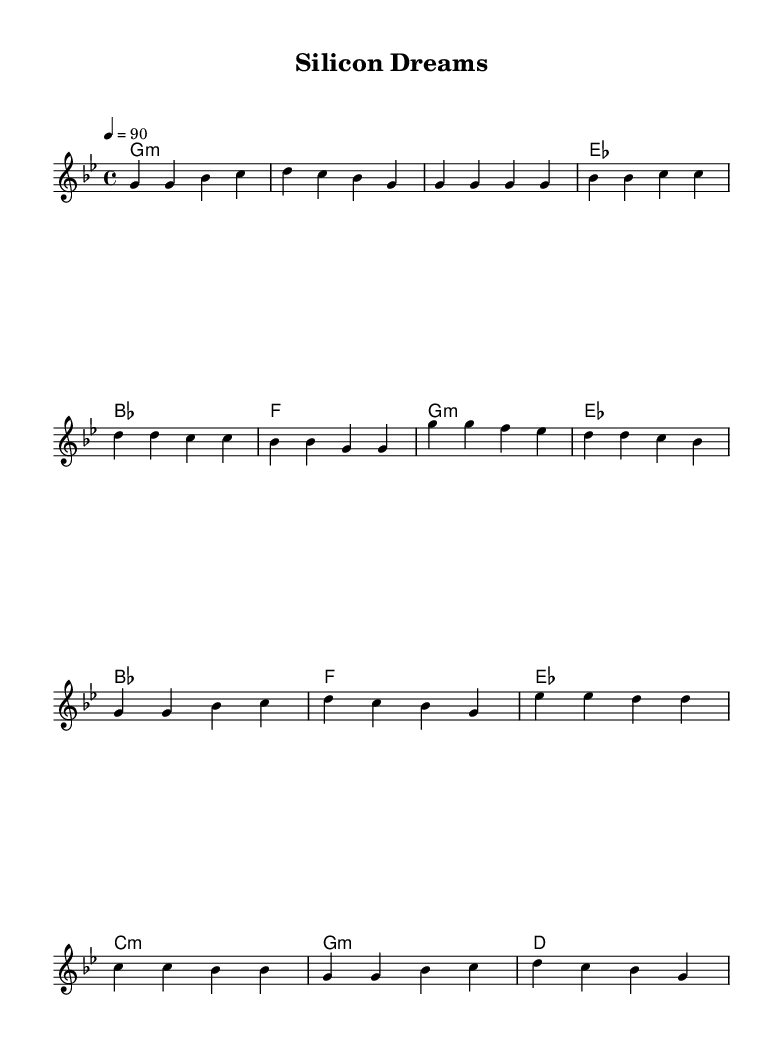What is the key signature of this music? The key signature is G minor, which includes B flat and E flat.
Answer: G minor What is the time signature of this music? The time signature is 4/4, indicating that there are four beats per measure.
Answer: 4/4 What is the tempo marking for this piece? The tempo marking indicates that the music should be played at a speed of 90 beats per minute.
Answer: 90 How many measures are in the verse section? The verse section consists of 4 measures, which can be counted directly from the melody section in the score.
Answer: 4 What is the first chord in the chorus? The first chord in the chorus is G minor, as indicated by the chord notation in the harmony section.
Answer: G minor What is the relationship between the chord progressions in the verse and the chorus? The chord progressions in both sections share the same chords, beginning with G minor, creating a coherent structure throughout the piece.
Answer: They are the same What rap theme is emphasized in the lyrics of this piece? The rap theme emphasizes tech entrepreneurship and startup culture, reflecting modern challenges and innovations in the tech industry.
Answer: Tech entrepreneurship 